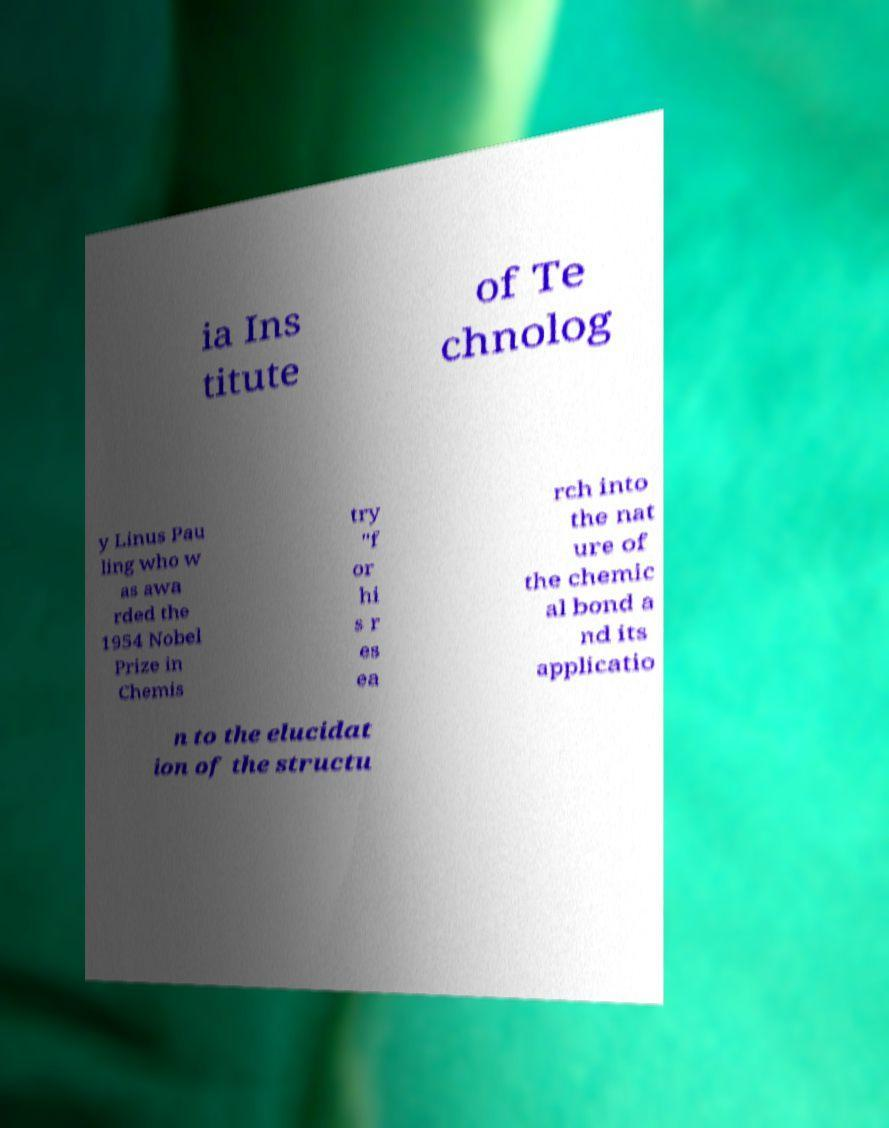I need the written content from this picture converted into text. Can you do that? ia Ins titute of Te chnolog y Linus Pau ling who w as awa rded the 1954 Nobel Prize in Chemis try "f or hi s r es ea rch into the nat ure of the chemic al bond a nd its applicatio n to the elucidat ion of the structu 